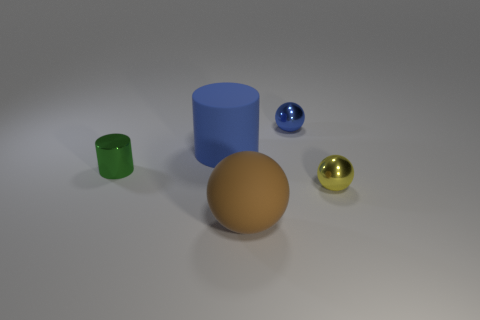Subtract 1 balls. How many balls are left? 2 Add 5 yellow rubber blocks. How many objects exist? 10 Subtract all spheres. How many objects are left? 2 Add 5 red shiny things. How many red shiny things exist? 5 Subtract 0 brown cubes. How many objects are left? 5 Subtract all brown matte objects. Subtract all small yellow objects. How many objects are left? 3 Add 1 rubber spheres. How many rubber spheres are left? 2 